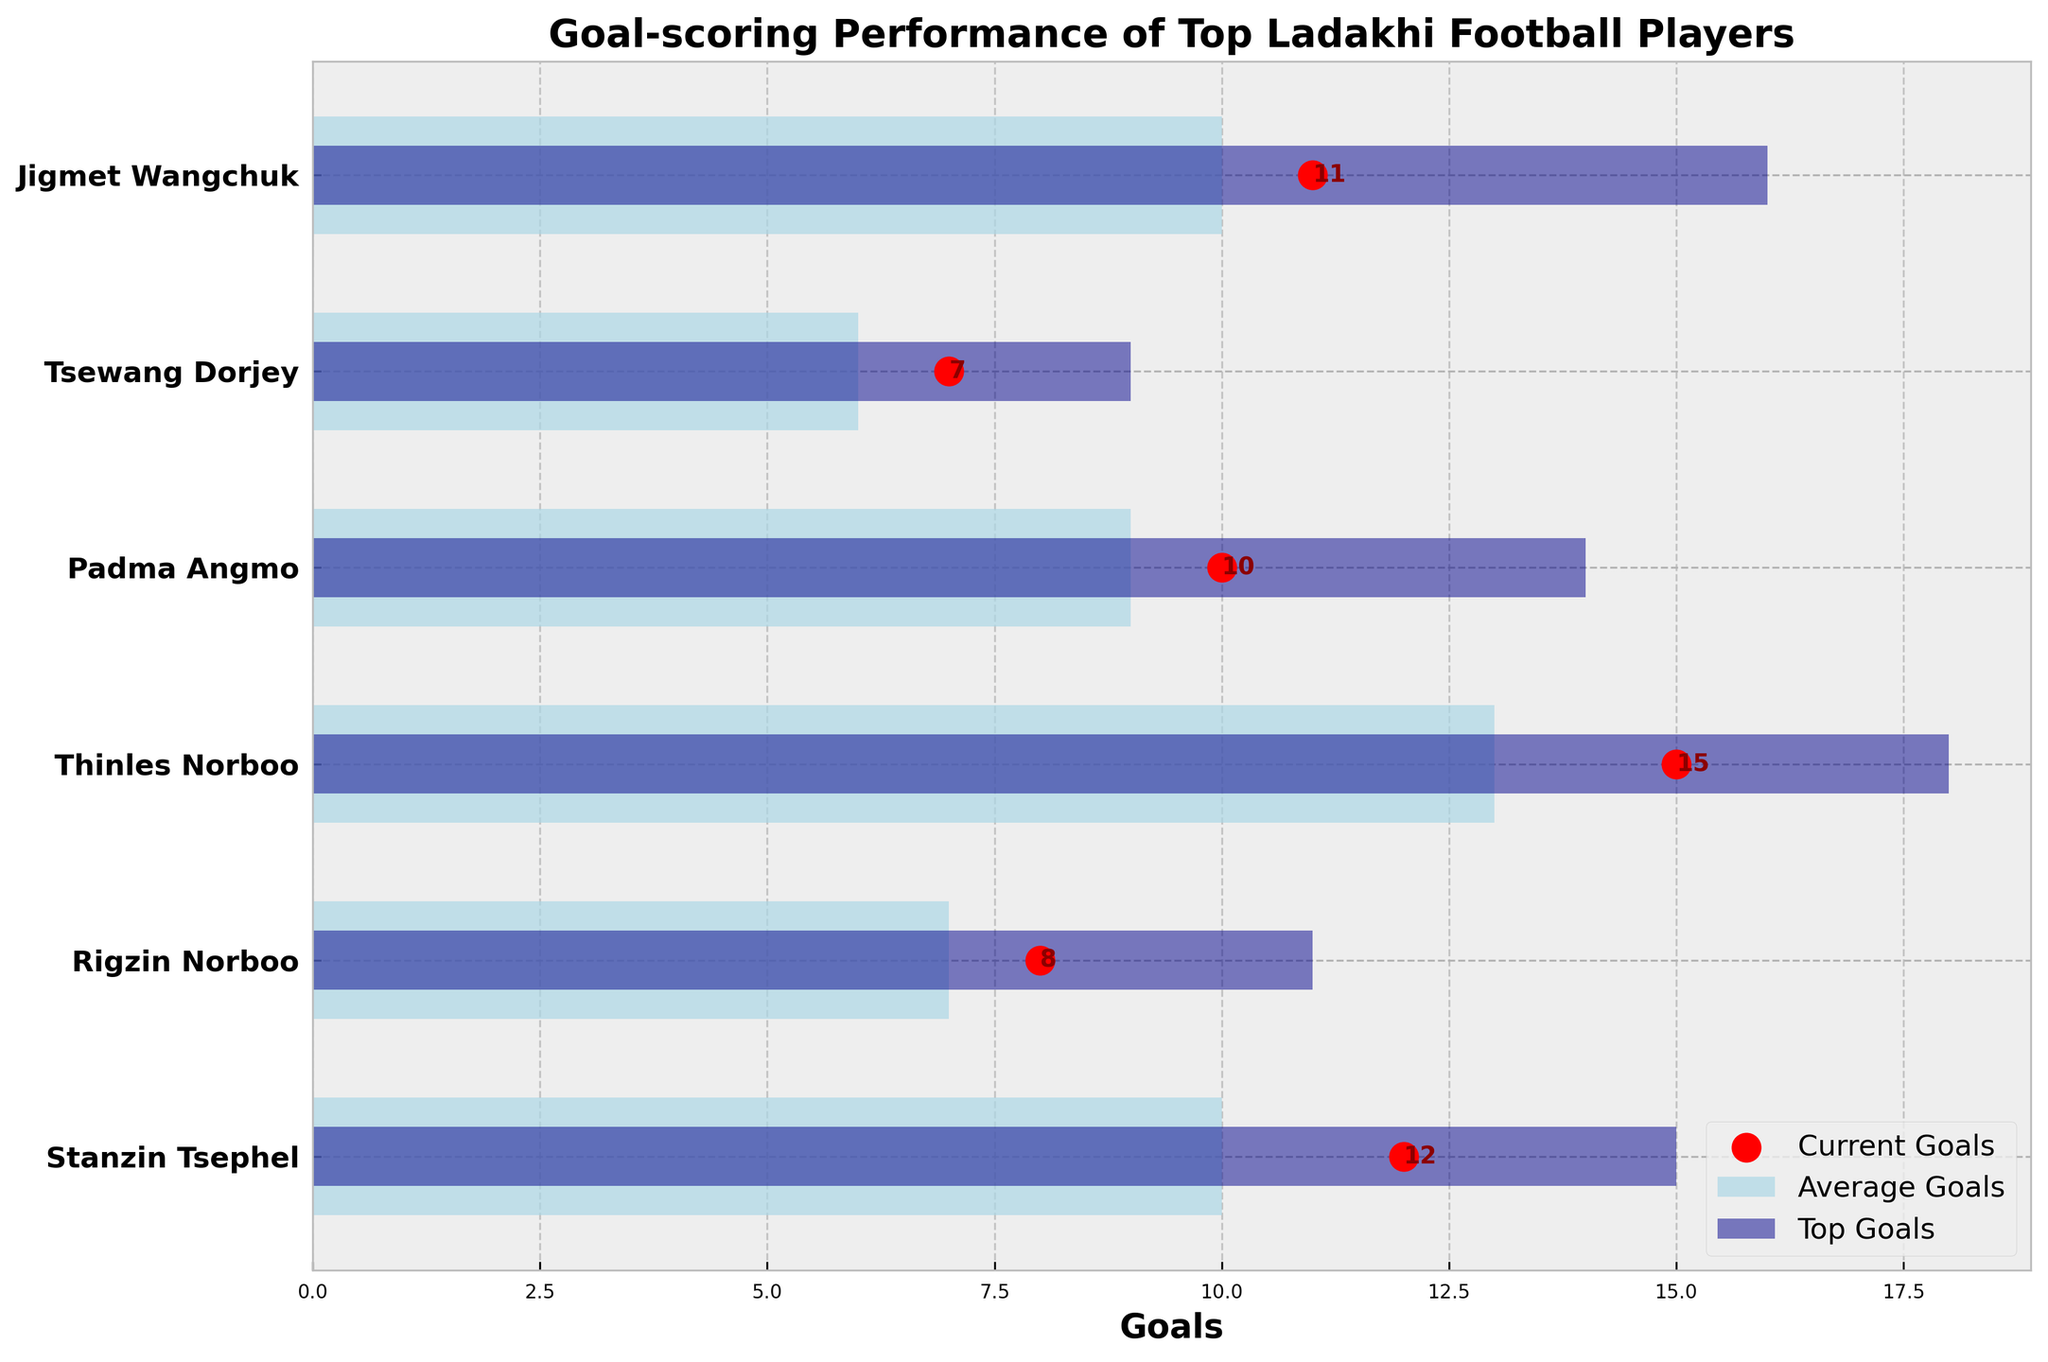What's the title of the chart? The title of the chart is displayed at the top of the figure. It states the main focus of the plot.
Answer: Goal-scoring Performance of Top Ladakhi Football Players How many players have a current goal count higher than their average goals? Compare the current goals with the average goals for each player in the plot. Count the number of players who have a higher current goal count.
Answer: Four Which player has the highest number of current goals? Look at the red scatter points representing current goals and identify the highest one.
Answer: Thinles Norboo Which player has the smallest difference between current goals and average goals? Calculate the difference between current goals and average goals for each player and find the smallest one.
Answer: Jigmet Wangchuk How much higher are Rigzin Norboo's top goals compared to his current goals? Subtract Rigzin Norboo's current goals from his top goals.
Answer: 3 Who has a higher current goal count, Padma Angmo or Jigmet Wangchuk? Compare the red scatter points for current goals between Padma Angmo and Jigmet Wangchuk.
Answer: Jigmet Wangchuk Which player’s current goals are exactly equal to their average goals? Compare each player's current goals with their average goals and identify any matches.
Answer: Jigmet Wangchuk How many more goals does Stanzin Tsephel need to reach his top goal record? Subtract Stanzin Tsephel's current goals from his top goals.
Answer: 3 What’s the highest number of average goals among all players? Look at the light blue bars representing average goals and find the highest one.
Answer: 13 Which player’s top goal count is more than double their average goals? For each player, check if their top goals are more than twice their average goals.
Answer: None 